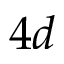<formula> <loc_0><loc_0><loc_500><loc_500>4 d</formula> 